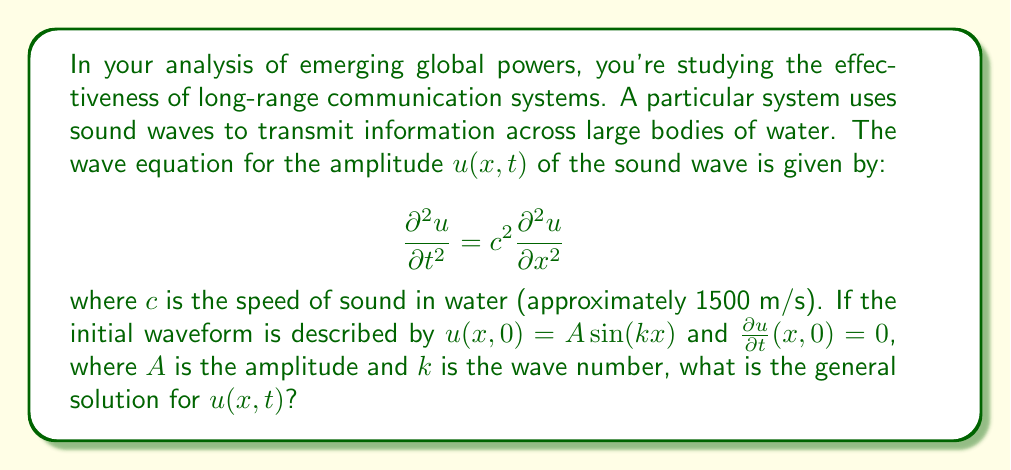Teach me how to tackle this problem. Let's approach this step-by-step:

1) The general solution for the wave equation with the given initial conditions is of the form:

   $$u(x,t) = F(x-ct) + G(x+ct)$$

   where $F$ and $G$ are arbitrary functions.

2) Given the initial condition $u(x,0) = A \sin(kx)$, we can write:

   $$F(x) + G(x) = A \sin(kx)$$

3) The second initial condition $\frac{\partial u}{\partial t}(x,0) = 0$ implies:

   $$-cF'(x) + cG'(x) = 0$$
   
   or $F'(x) = G'(x)$

4) From steps 2 and 3, we can deduce:

   $$F(x) = G(x) = \frac{A}{2} \sin(kx)$$

5) Substituting these into the general solution:

   $$u(x,t) = \frac{A}{2} \sin(k(x-ct)) + \frac{A}{2} \sin(k(x+ct))$$

6) Using the trigonometric identity for the sum of sines:

   $$\sin A + \sin B = 2 \sin(\frac{A+B}{2}) \cos(\frac{A-B}{2})$$

7) We get:

   $$u(x,t) = A \sin(kx) \cos(kct)$$

This is the general solution for the given wave equation and initial conditions.
Answer: $u(x,t) = A \sin(kx) \cos(kct)$ 